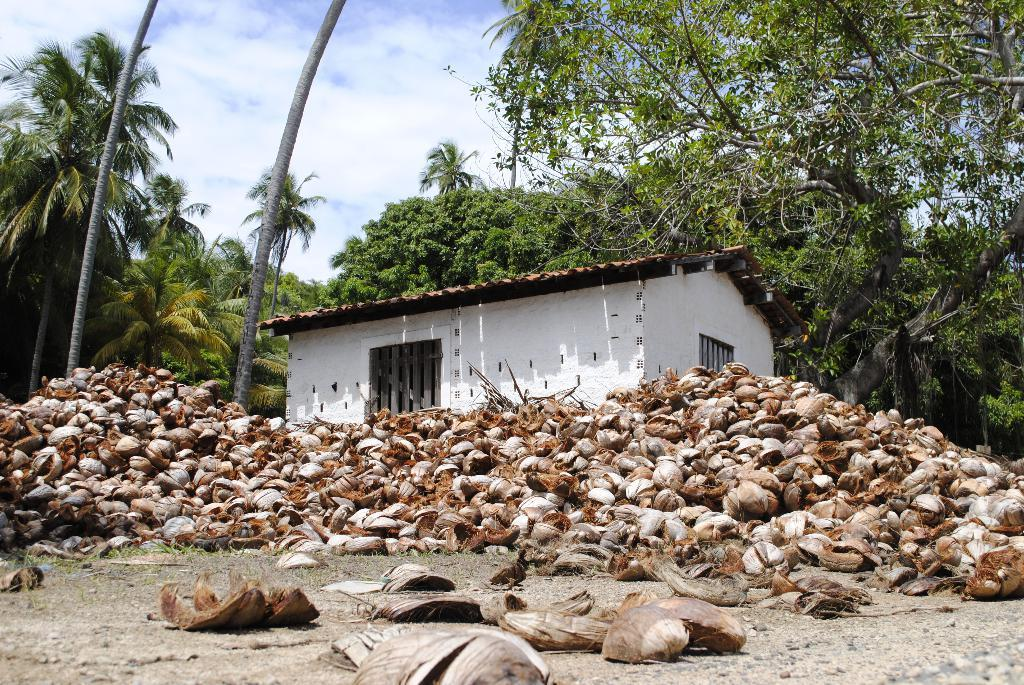What can be seen in the image that is related to coconut? There is residue of coconut in the image. What type of structure is visible in the image? There is a building in the image. What can be seen in the background of the image? There are trees in the background of the image. What is the condition of the sky in the image? The sky is clear in the image. What year is depicted in the image? There is no indication of a specific year in the image. What type of debt is being discussed in the image? There is no mention of debt in the image. 